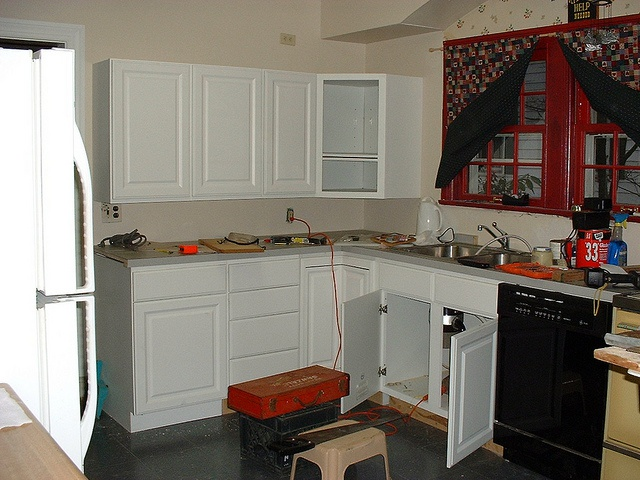Describe the objects in this image and their specific colors. I can see refrigerator in gray, white, darkgray, and black tones, oven in gray and black tones, bottle in gray, black, brown, and maroon tones, sink in gray and black tones, and potted plant in gray and black tones in this image. 